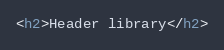<code> <loc_0><loc_0><loc_500><loc_500><_HTML_><h2>Header library</h2>
</code> 